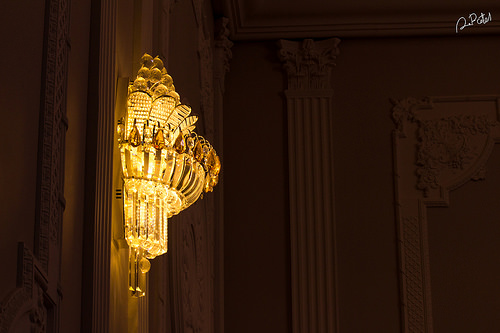<image>
Is the light in front of the wall? Yes. The light is positioned in front of the wall, appearing closer to the camera viewpoint. 